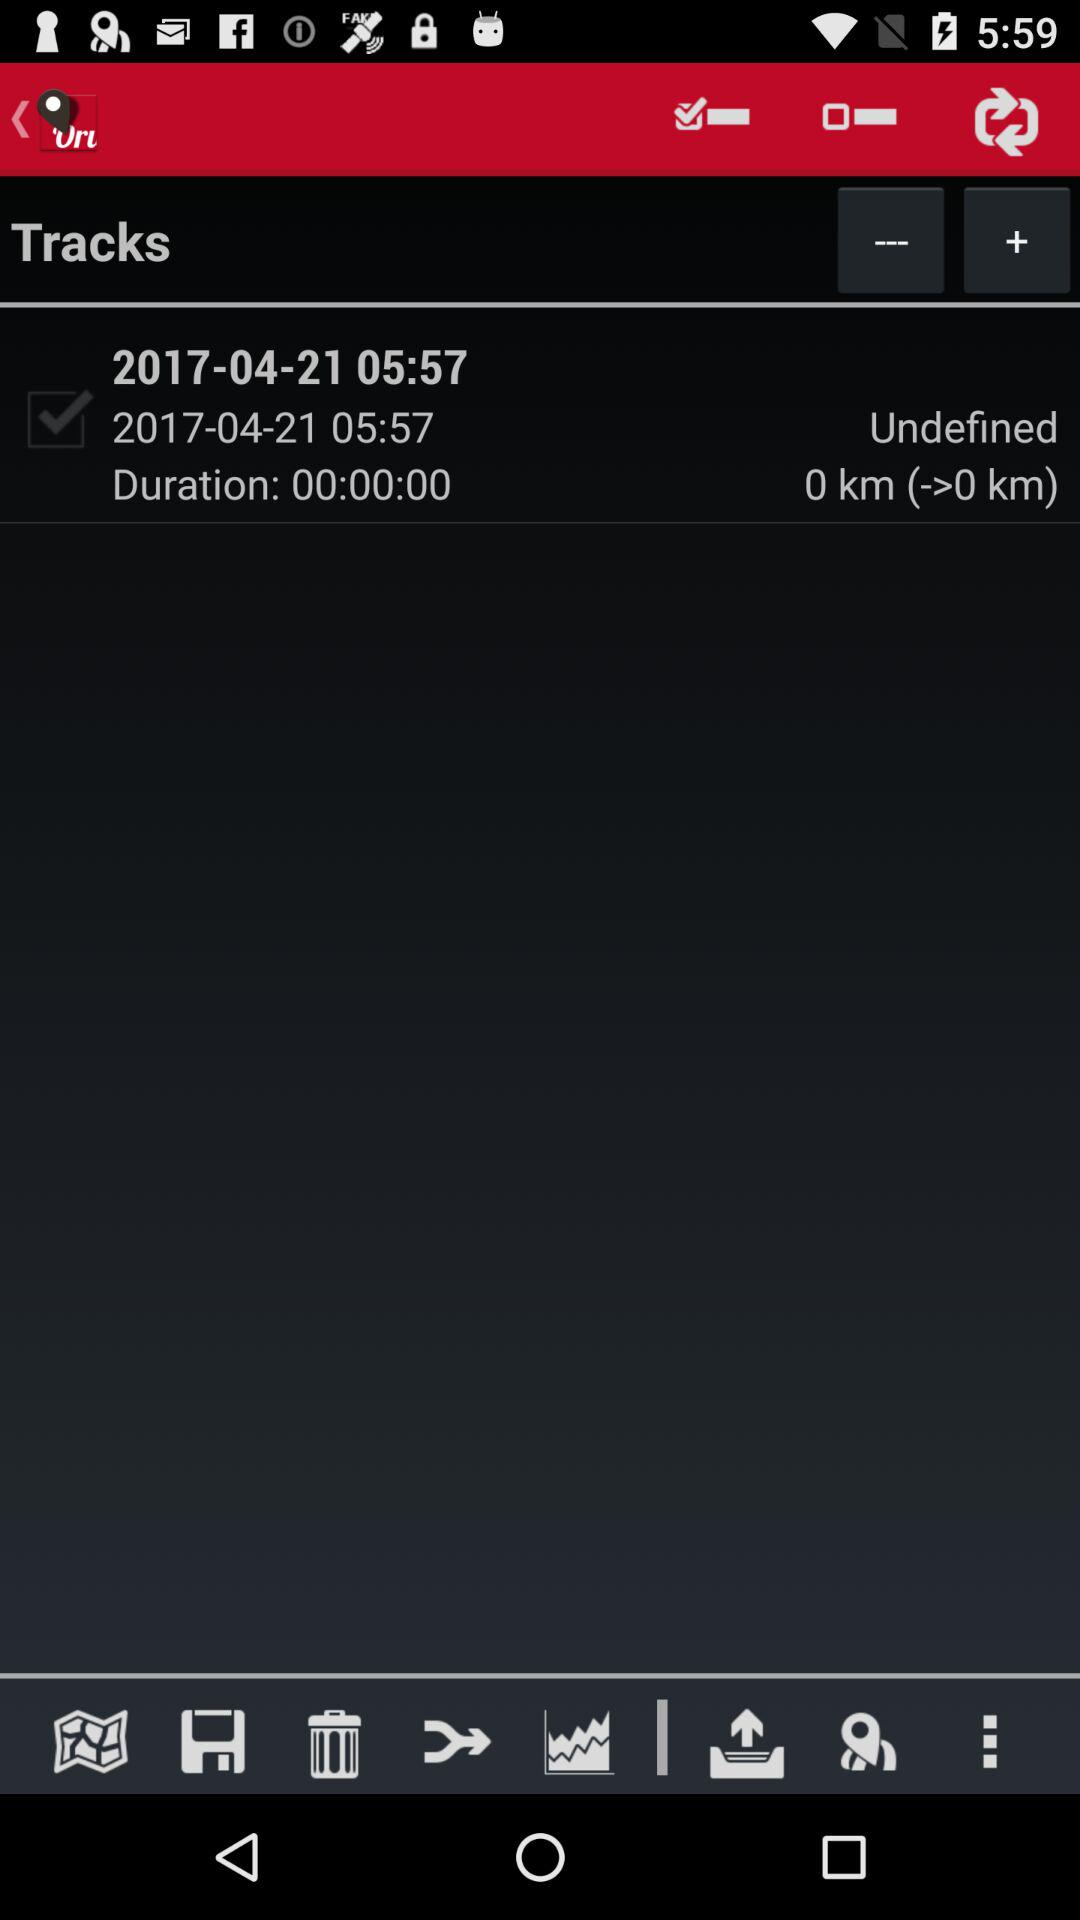What is the time of the tracks? The time of the track is 05:57. 